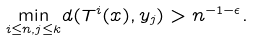<formula> <loc_0><loc_0><loc_500><loc_500>\underset { i \leq n , j \leq k } { \min } d ( T ^ { i } ( x ) , y _ { j } ) > n ^ { - 1 - \epsilon } .</formula> 